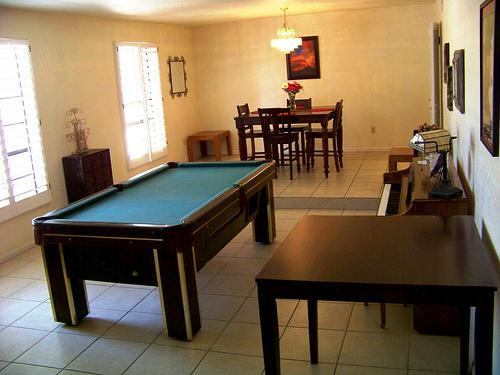Question: when was this picture take?
Choices:
A. Daytime.
B. Last week.
C. Yesterday.
D. Today.
Answer with the letter. Answer: A Question: how many vases in this picture?
Choices:
A. Two.
B. Three.
C. Four.
D. Five.
Answer with the letter. Answer: A Question: what is the floor made of?
Choices:
A. Wood.
B. Concrete.
C. Carpet.
D. Tile.
Answer with the letter. Answer: D Question: where was this picture taken?
Choices:
A. Bedroom.
B. Bathroom.
C. Kitchen.
D. Inside a house.
Answer with the letter. Answer: D Question: how many chairs around the dining table?
Choices:
A. Five.
B. Six.
C. Four.
D. Eight.
Answer with the letter. Answer: C Question: what color are the walls?
Choices:
A. Pink.
B. Blue.
C. White.
D. Brown.
Answer with the letter. Answer: C Question: what is the lamp sitting on?
Choices:
A. Table.
B. Piano.
C. Floor.
D. Desk.
Answer with the letter. Answer: B 